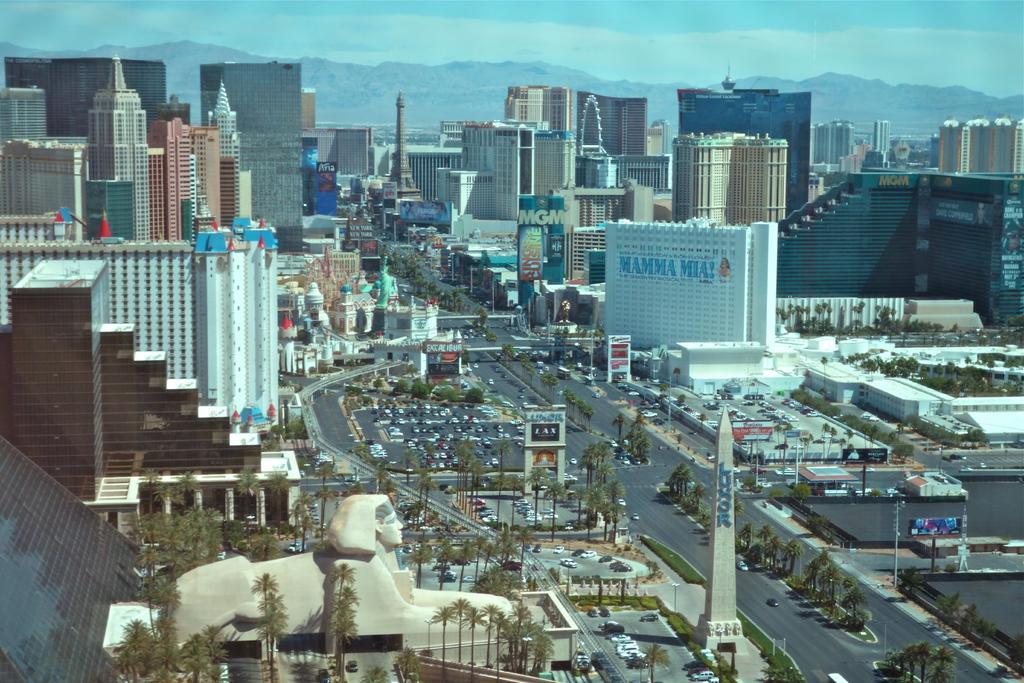Describe this image in one or two sentences. This is aerial view of a city. In the foreground of the picture there are sculptures, trees, cars, roads, buildings, current poles and other objects. In the center of the picture there are buildings, trees and road. In the background there are hills and sky. 